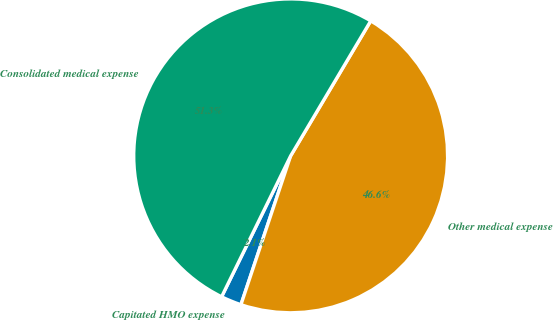Convert chart to OTSL. <chart><loc_0><loc_0><loc_500><loc_500><pie_chart><fcel>Capitated HMO expense<fcel>Other medical expense<fcel>Consolidated medical expense<nl><fcel>2.12%<fcel>46.61%<fcel>51.27%<nl></chart> 